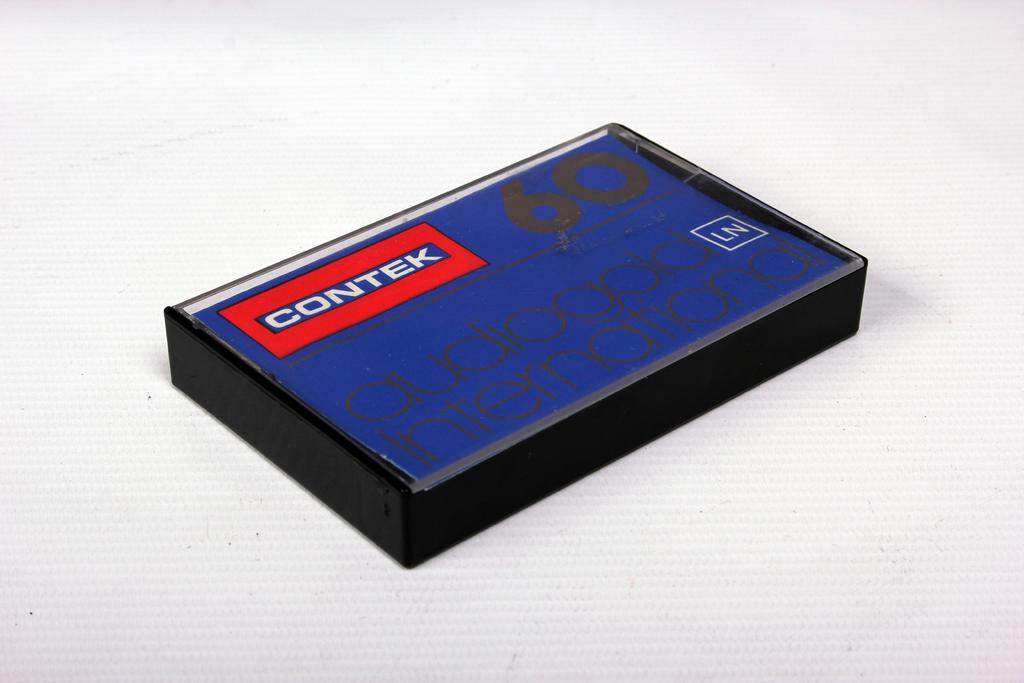Who makes these?
Your response must be concise. Contek. What is the duration?
Keep it short and to the point. 60. 